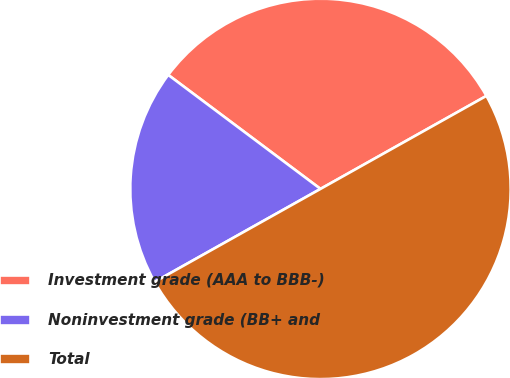Convert chart. <chart><loc_0><loc_0><loc_500><loc_500><pie_chart><fcel>Investment grade (AAA to BBB-)<fcel>Noninvestment grade (BB+ and<fcel>Total<nl><fcel>31.64%<fcel>18.36%<fcel>50.0%<nl></chart> 